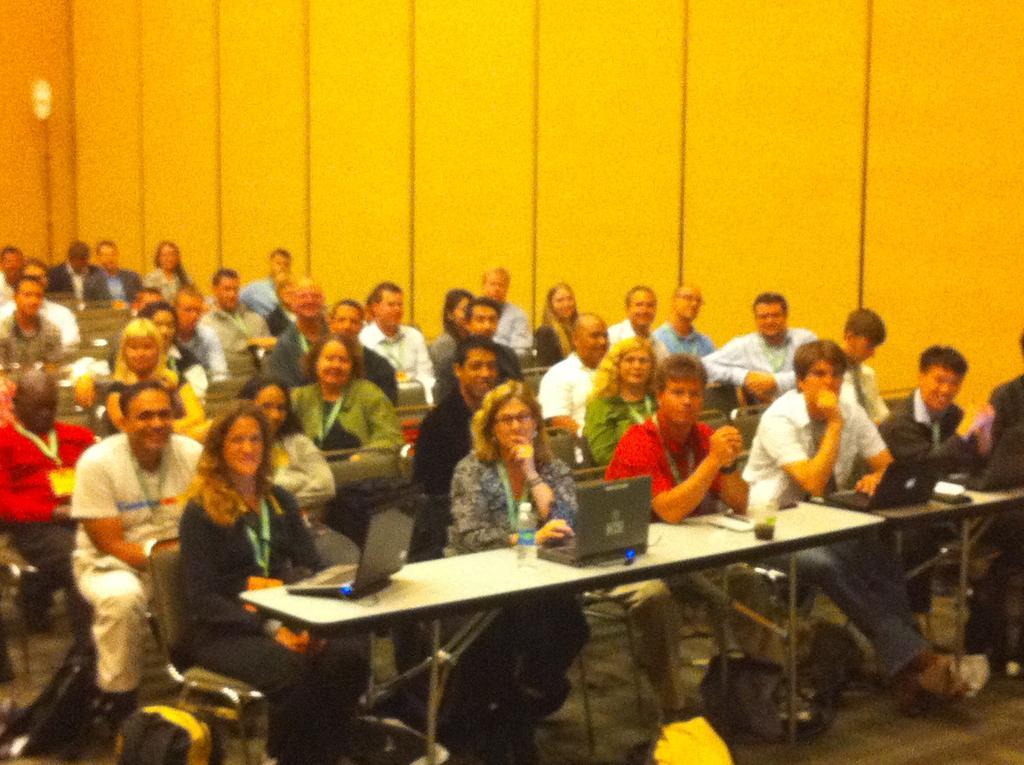Can you describe this image briefly? There are few persons sitting in chairs and there is a table in front of them which has few laptops on it and there are few other persons sitting behind them. 